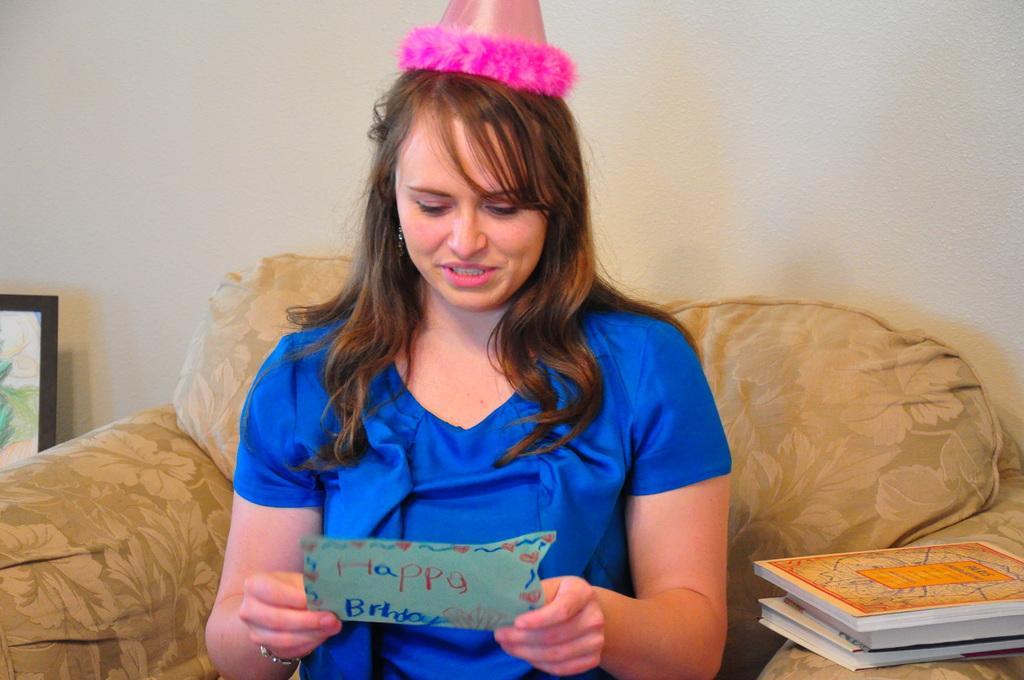How would you summarize this image in a sentence or two? In this picture there is a woman sitting on a chair and holding a card and wore cap, beside her we can see books. In the background of the image we can see frame and wall. 